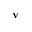Convert formula to latex. <formula><loc_0><loc_0><loc_500><loc_500>v</formula> 